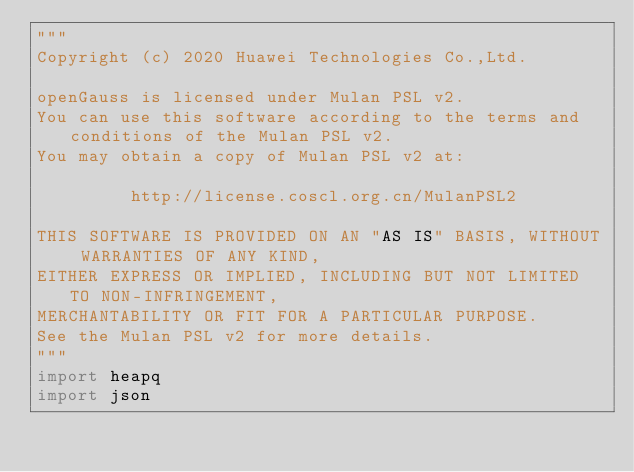Convert code to text. <code><loc_0><loc_0><loc_500><loc_500><_Python_>"""
Copyright (c) 2020 Huawei Technologies Co.,Ltd.

openGauss is licensed under Mulan PSL v2.
You can use this software according to the terms and conditions of the Mulan PSL v2.
You may obtain a copy of Mulan PSL v2 at:

         http://license.coscl.org.cn/MulanPSL2

THIS SOFTWARE IS PROVIDED ON AN "AS IS" BASIS, WITHOUT WARRANTIES OF ANY KIND,
EITHER EXPRESS OR IMPLIED, INCLUDING BUT NOT LIMITED TO NON-INFRINGEMENT,
MERCHANTABILITY OR FIT FOR A PARTICULAR PURPOSE.
See the Mulan PSL v2 for more details.
"""
import heapq
import json</code> 